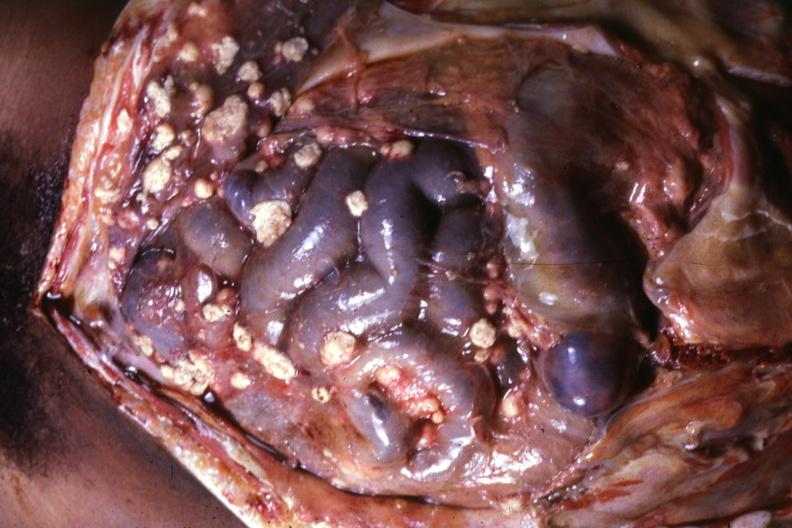s tuberculous peritonitis present?
Answer the question using a single word or phrase. Yes 